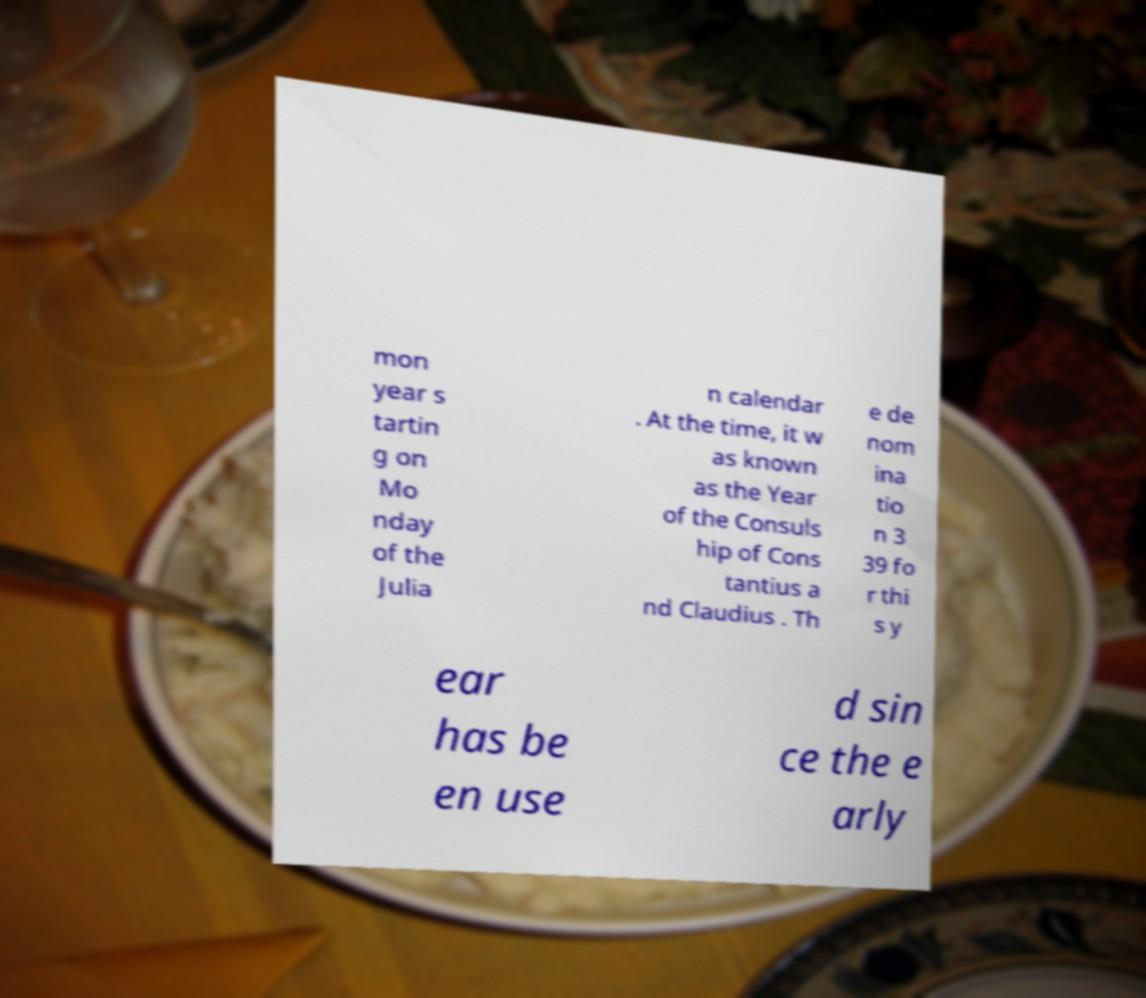Please identify and transcribe the text found in this image. mon year s tartin g on Mo nday of the Julia n calendar . At the time, it w as known as the Year of the Consuls hip of Cons tantius a nd Claudius . Th e de nom ina tio n 3 39 fo r thi s y ear has be en use d sin ce the e arly 